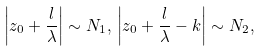Convert formula to latex. <formula><loc_0><loc_0><loc_500><loc_500>\left | z _ { 0 } + \frac { l } { \lambda } \right | \sim N _ { 1 } , \, \left | z _ { 0 } + \frac { l } { \lambda } - k \right | \sim N _ { 2 } ,</formula> 